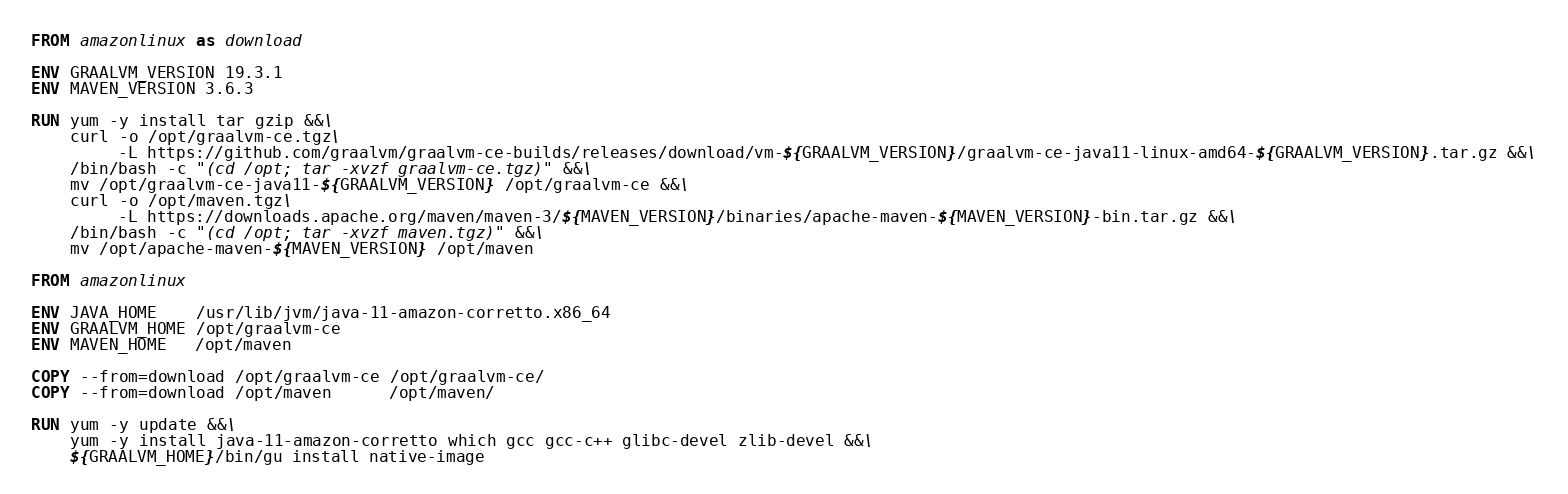Convert code to text. <code><loc_0><loc_0><loc_500><loc_500><_Dockerfile_>FROM amazonlinux as download

ENV GRAALVM_VERSION 19.3.1
ENV MAVEN_VERSION 3.6.3

RUN yum -y install tar gzip &&\
    curl -o /opt/graalvm-ce.tgz\
         -L https://github.com/graalvm/graalvm-ce-builds/releases/download/vm-${GRAALVM_VERSION}/graalvm-ce-java11-linux-amd64-${GRAALVM_VERSION}.tar.gz &&\
    /bin/bash -c "(cd /opt; tar -xvzf graalvm-ce.tgz)" &&\
    mv /opt/graalvm-ce-java11-${GRAALVM_VERSION} /opt/graalvm-ce &&\
    curl -o /opt/maven.tgz\
         -L https://downloads.apache.org/maven/maven-3/${MAVEN_VERSION}/binaries/apache-maven-${MAVEN_VERSION}-bin.tar.gz &&\
    /bin/bash -c "(cd /opt; tar -xvzf maven.tgz)" &&\
    mv /opt/apache-maven-${MAVEN_VERSION} /opt/maven

FROM amazonlinux

ENV JAVA_HOME    /usr/lib/jvm/java-11-amazon-corretto.x86_64
ENV GRAALVM_HOME /opt/graalvm-ce
ENV MAVEN_HOME   /opt/maven

COPY --from=download /opt/graalvm-ce /opt/graalvm-ce/
COPY --from=download /opt/maven      /opt/maven/

RUN yum -y update &&\
    yum -y install java-11-amazon-corretto which gcc gcc-c++ glibc-devel zlib-devel &&\
    ${GRAALVM_HOME}/bin/gu install native-image

</code> 